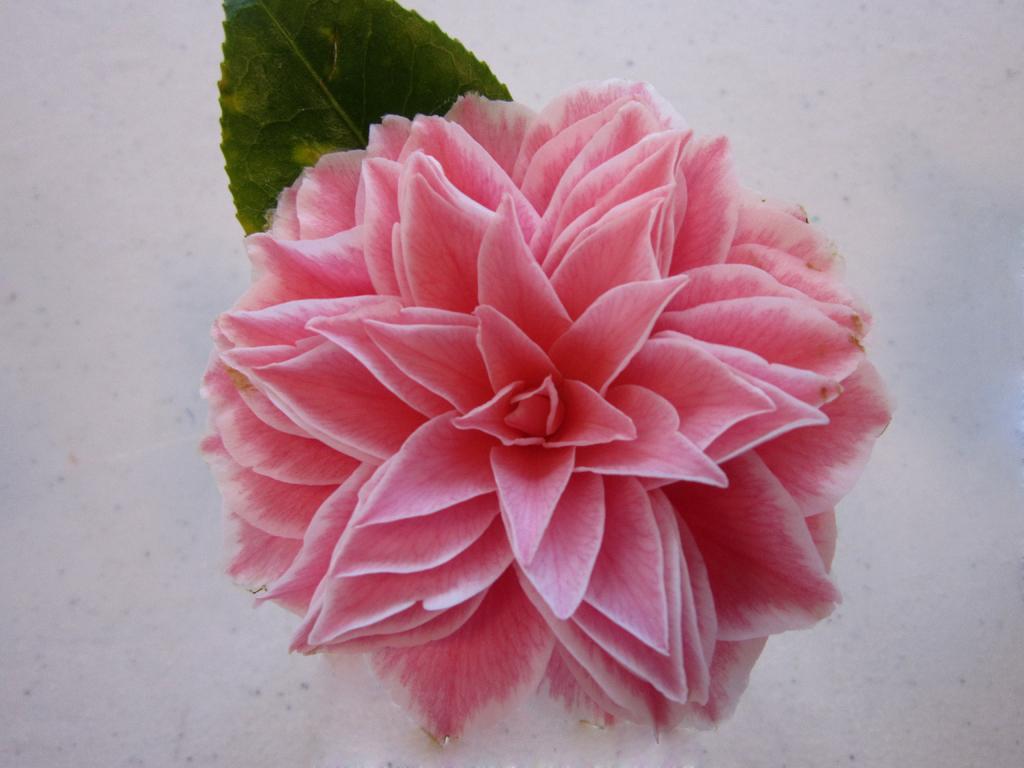Please provide a concise description of this image. In this image in the center there is one flower, and in the background there is a leaf and wall. 